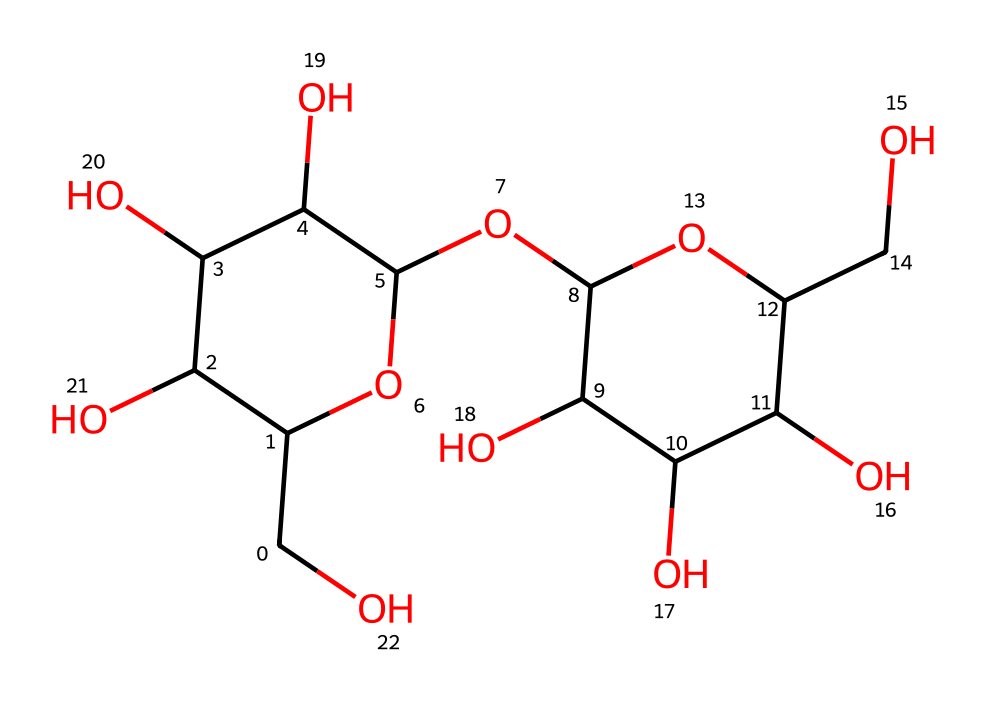What is the main type of carbohydrate represented by this structure? This structure represents starch, which is a polysaccharide made up of multiple glucose units connected by glycosidic bonds.
Answer: polysaccharide How many glucose units are present in this structure? By analyzing the SMILES representation, we can identify that there are several distinct glucose monomers. Counting reveals that there are four glucose units.
Answer: four What type of glycosidic linkage connects the glucose units in this structure? The SMILES representation indicates that the glucose units are connected predominantly by alpha-1,4-glycosidic links, which is typical for starch.
Answer: alpha-1,4 What is the total number of oxygen atoms in this starch structure? By examining the SMILES representation, we can find the oxygen atoms. There are six oxygen atoms when counting from the structure.
Answer: six How many hydroxyl (–OH) groups are attached to the glucose units in this molecule? Each glucose monomer has five hydroxyl groups, and with four glucose units present, the total would be twenty.
Answer: twenty What property of starch allows it to act as an energy source in diets? Starch is a polymer of glucose, which can be easily broken down into glucose molecules by enzymes to provide energy.
Answer: energy source 